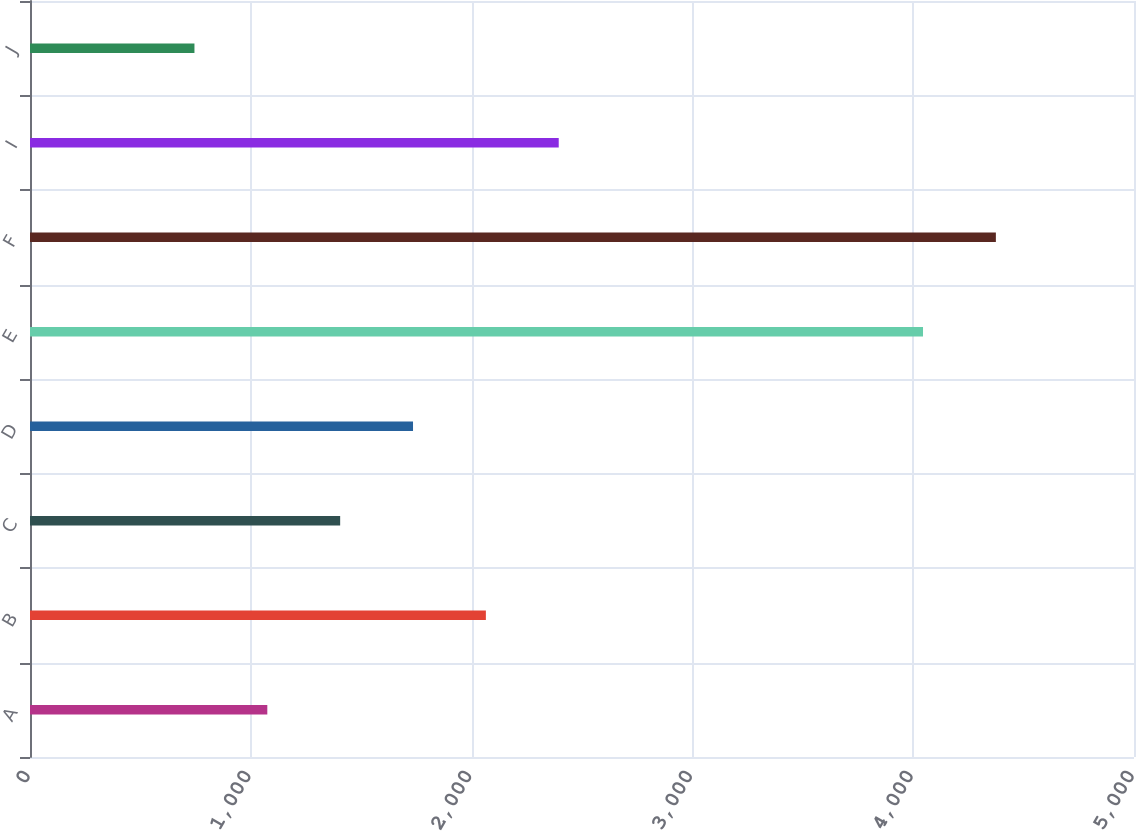<chart> <loc_0><loc_0><loc_500><loc_500><bar_chart><fcel>A<fcel>B<fcel>C<fcel>D<fcel>E<fcel>F<fcel>I<fcel>J<nl><fcel>1074.76<fcel>2064.64<fcel>1404.72<fcel>1734.68<fcel>4044.44<fcel>4374.4<fcel>2394.61<fcel>744.79<nl></chart> 